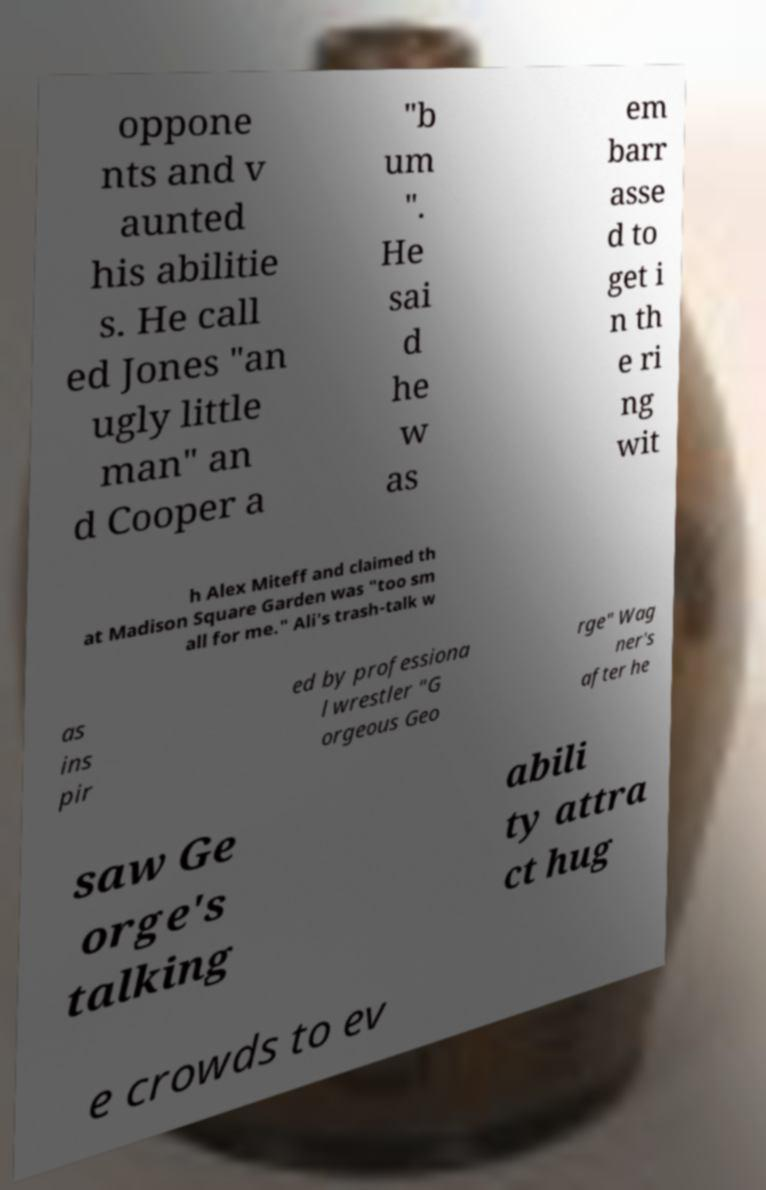For documentation purposes, I need the text within this image transcribed. Could you provide that? oppone nts and v aunted his abilitie s. He call ed Jones "an ugly little man" an d Cooper a "b um ". He sai d he w as em barr asse d to get i n th e ri ng wit h Alex Miteff and claimed th at Madison Square Garden was "too sm all for me." Ali's trash-talk w as ins pir ed by professiona l wrestler "G orgeous Geo rge" Wag ner's after he saw Ge orge's talking abili ty attra ct hug e crowds to ev 